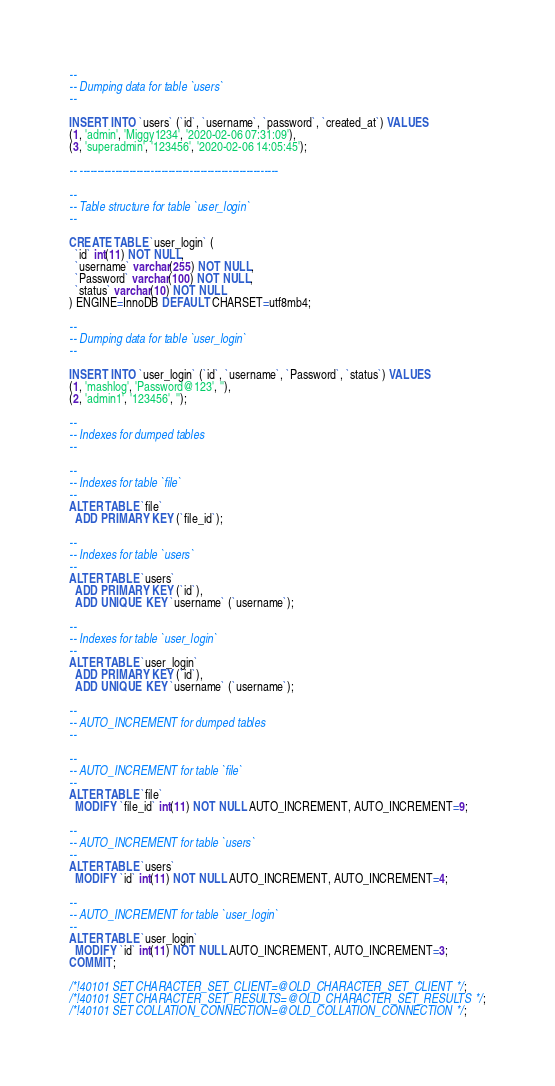<code> <loc_0><loc_0><loc_500><loc_500><_SQL_>
--
-- Dumping data for table `users`
--

INSERT INTO `users` (`id`, `username`, `password`, `created_at`) VALUES
(1, 'admin', 'Miggy1234', '2020-02-06 07:31:09'),
(3, 'superadmin', '123456', '2020-02-06 14:05:45');

-- --------------------------------------------------------

--
-- Table structure for table `user_login`
--

CREATE TABLE `user_login` (
  `id` int(11) NOT NULL,
  `username` varchar(255) NOT NULL,
  `Password` varchar(100) NOT NULL,
  `status` varchar(10) NOT NULL
) ENGINE=InnoDB DEFAULT CHARSET=utf8mb4;

--
-- Dumping data for table `user_login`
--

INSERT INTO `user_login` (`id`, `username`, `Password`, `status`) VALUES
(1, 'mashlog', 'Password@123', ''),
(2, 'admin1', '123456', '');

--
-- Indexes for dumped tables
--

--
-- Indexes for table `file`
--
ALTER TABLE `file`
  ADD PRIMARY KEY (`file_id`);

--
-- Indexes for table `users`
--
ALTER TABLE `users`
  ADD PRIMARY KEY (`id`),
  ADD UNIQUE KEY `username` (`username`);

--
-- Indexes for table `user_login`
--
ALTER TABLE `user_login`
  ADD PRIMARY KEY (`id`),
  ADD UNIQUE KEY `username` (`username`);

--
-- AUTO_INCREMENT for dumped tables
--

--
-- AUTO_INCREMENT for table `file`
--
ALTER TABLE `file`
  MODIFY `file_id` int(11) NOT NULL AUTO_INCREMENT, AUTO_INCREMENT=9;

--
-- AUTO_INCREMENT for table `users`
--
ALTER TABLE `users`
  MODIFY `id` int(11) NOT NULL AUTO_INCREMENT, AUTO_INCREMENT=4;

--
-- AUTO_INCREMENT for table `user_login`
--
ALTER TABLE `user_login`
  MODIFY `id` int(11) NOT NULL AUTO_INCREMENT, AUTO_INCREMENT=3;
COMMIT;

/*!40101 SET CHARACTER_SET_CLIENT=@OLD_CHARACTER_SET_CLIENT */;
/*!40101 SET CHARACTER_SET_RESULTS=@OLD_CHARACTER_SET_RESULTS */;
/*!40101 SET COLLATION_CONNECTION=@OLD_COLLATION_CONNECTION */;
</code> 